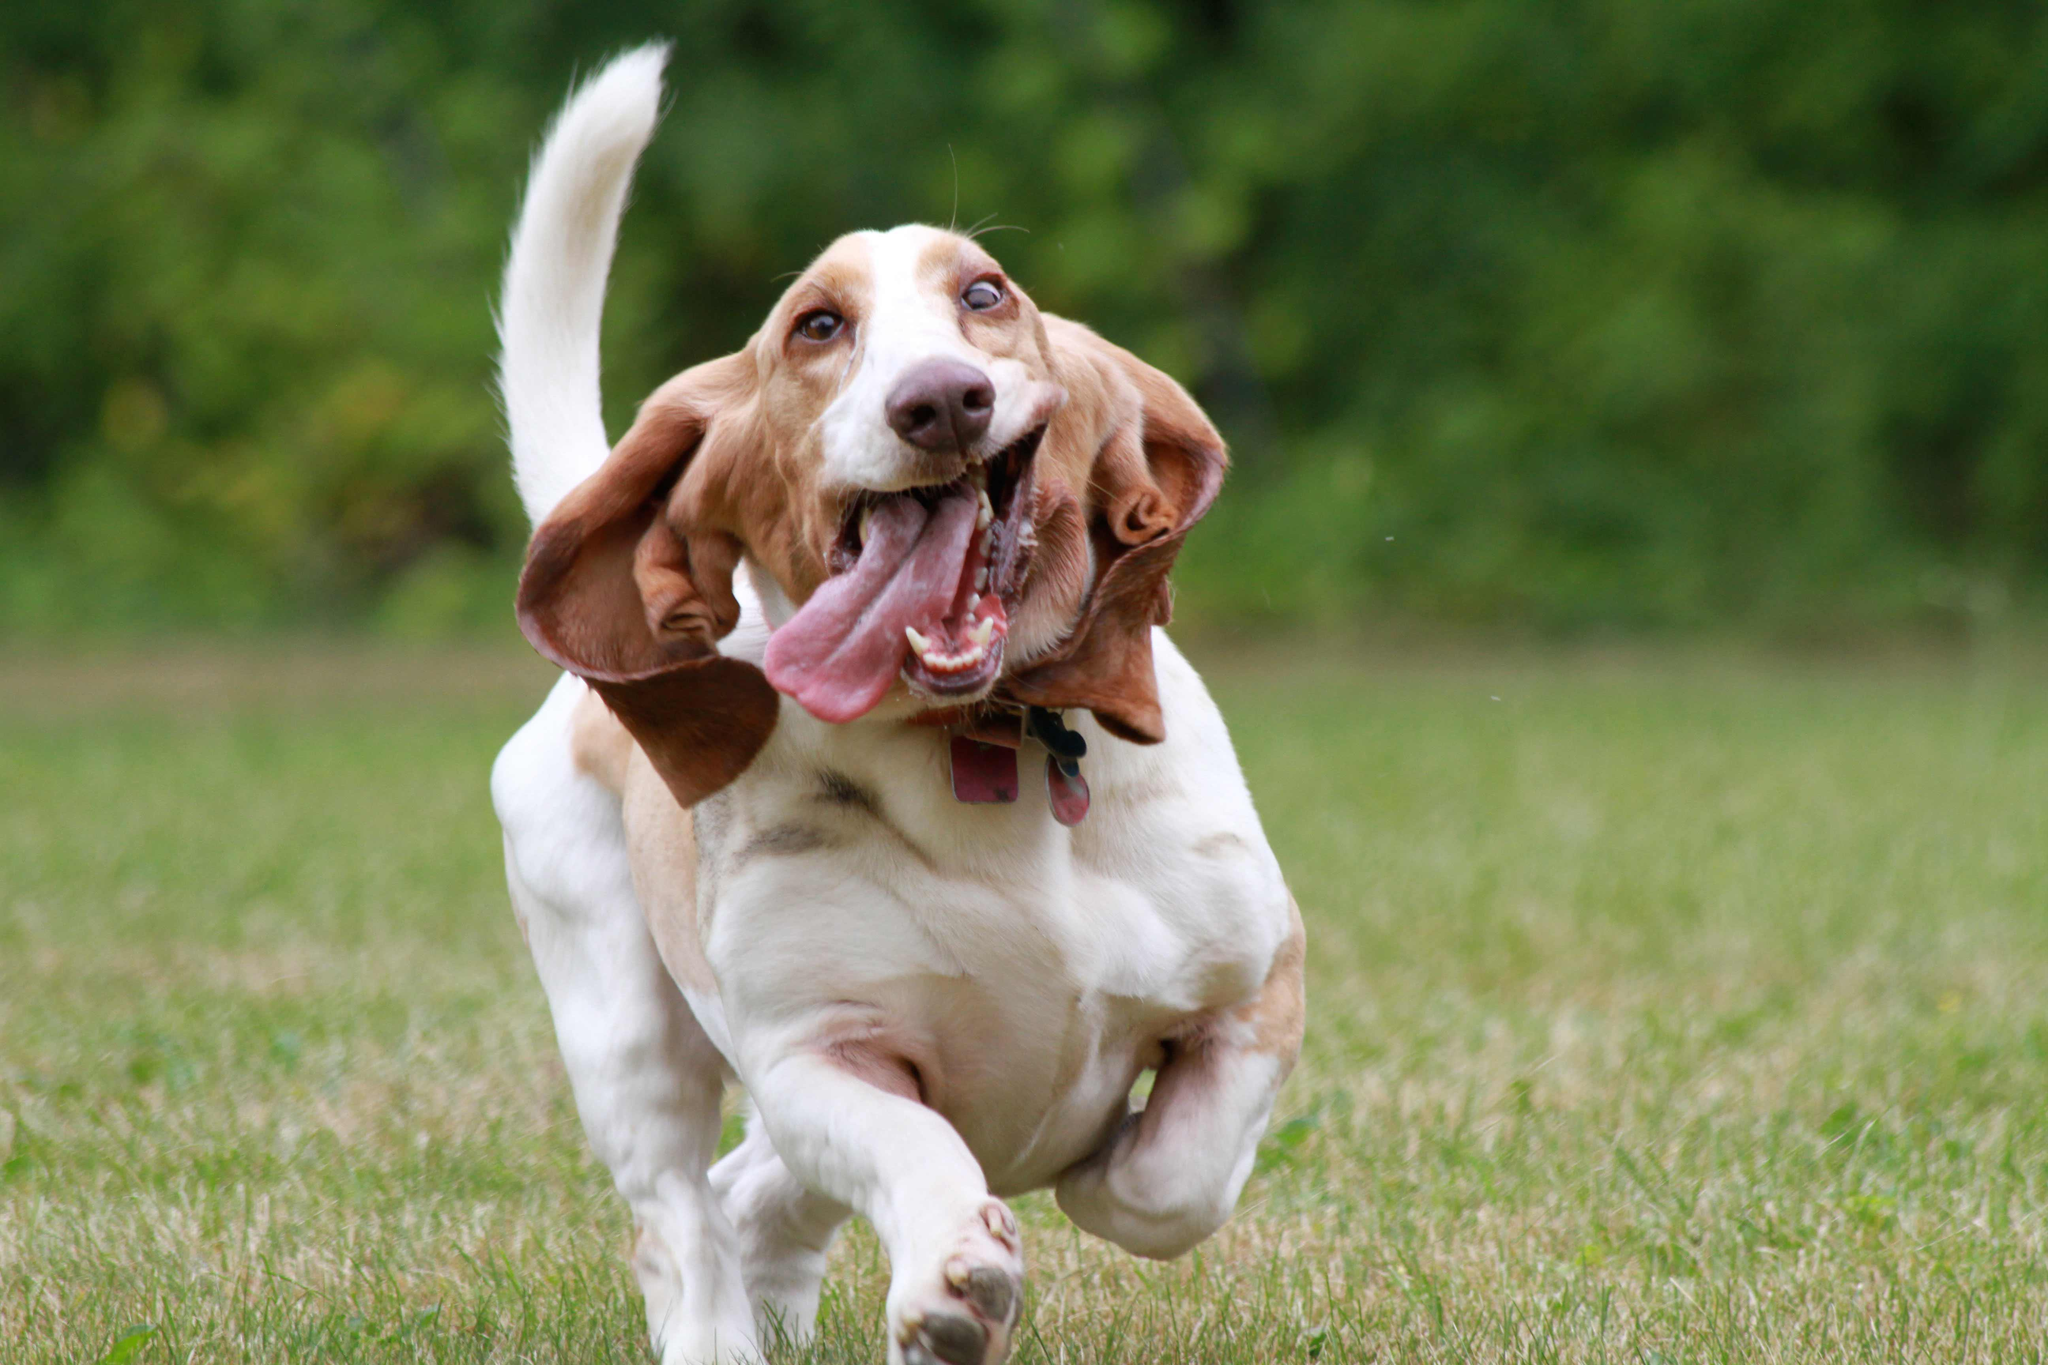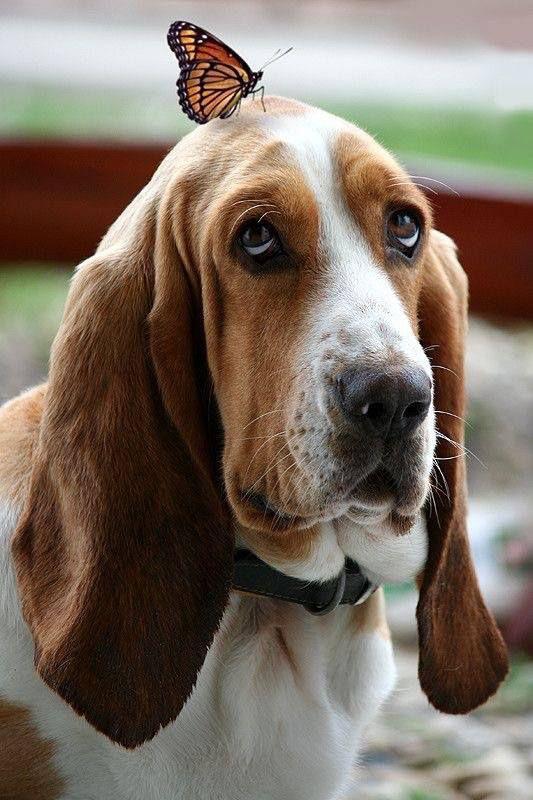The first image is the image on the left, the second image is the image on the right. Assess this claim about the two images: "Exactly one dog tongue can be seen in one of the images.". Correct or not? Answer yes or no. Yes. 